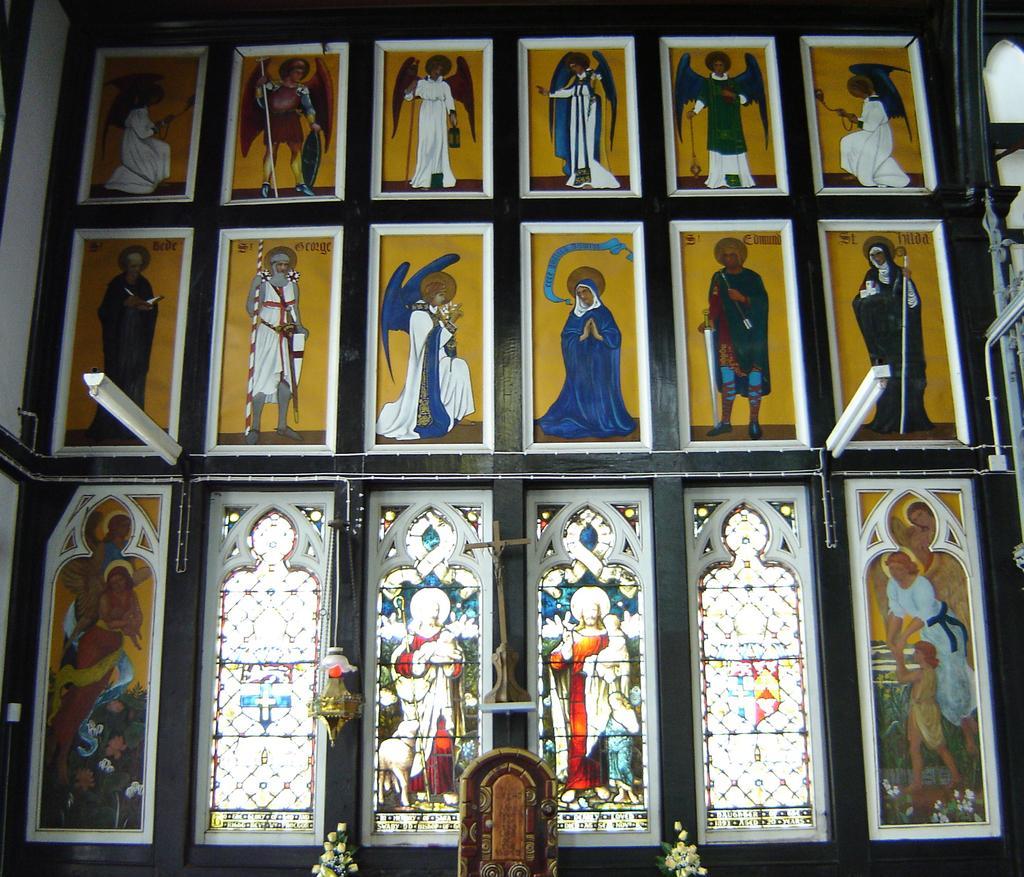Could you give a brief overview of what you see in this image? In this image there is a wall for that wall there are photo frames and glass windows and lights. 